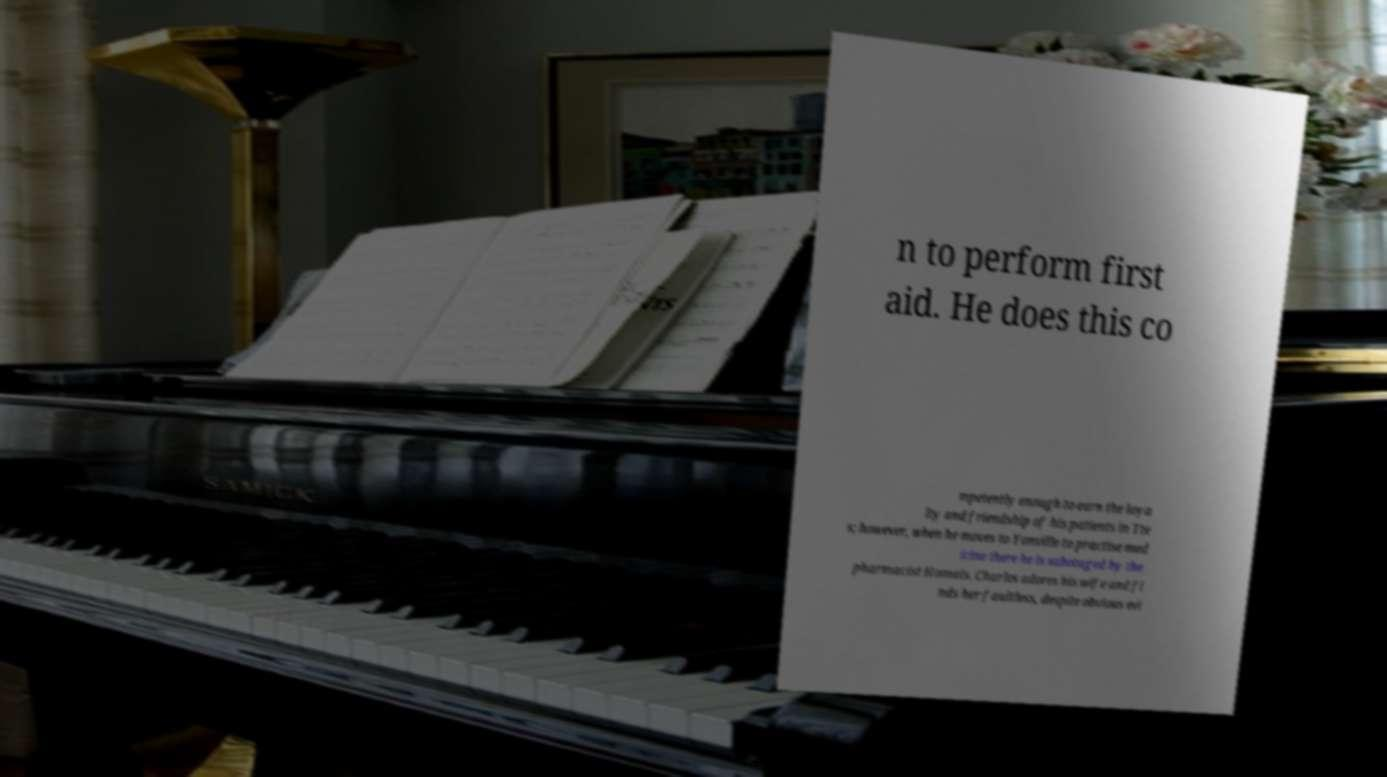Please read and relay the text visible in this image. What does it say? n to perform first aid. He does this co mpetently enough to earn the loya lty and friendship of his patients in Tte s; however, when he moves to Yonville to practise med icine there he is sabotaged by the pharmacist Homais. Charles adores his wife and fi nds her faultless, despite obvious evi 